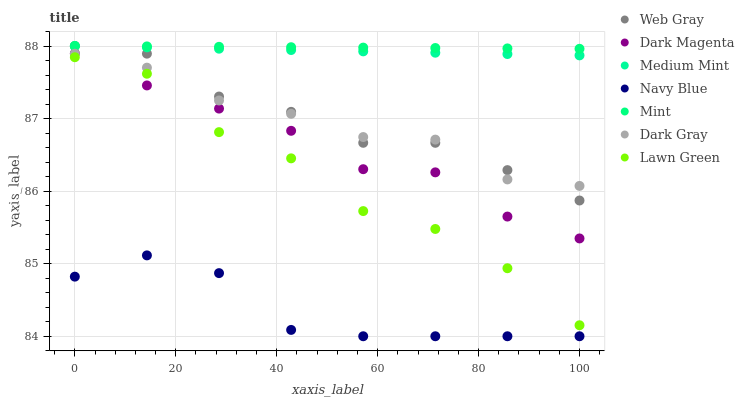Does Navy Blue have the minimum area under the curve?
Answer yes or no. Yes. Does Mint have the maximum area under the curve?
Answer yes or no. Yes. Does Lawn Green have the minimum area under the curve?
Answer yes or no. No. Does Lawn Green have the maximum area under the curve?
Answer yes or no. No. Is Mint the smoothest?
Answer yes or no. Yes. Is Lawn Green the roughest?
Answer yes or no. Yes. Is Web Gray the smoothest?
Answer yes or no. No. Is Web Gray the roughest?
Answer yes or no. No. Does Navy Blue have the lowest value?
Answer yes or no. Yes. Does Lawn Green have the lowest value?
Answer yes or no. No. Does Mint have the highest value?
Answer yes or no. Yes. Does Lawn Green have the highest value?
Answer yes or no. No. Is Dark Gray less than Medium Mint?
Answer yes or no. Yes. Is Medium Mint greater than Lawn Green?
Answer yes or no. Yes. Does Dark Gray intersect Web Gray?
Answer yes or no. Yes. Is Dark Gray less than Web Gray?
Answer yes or no. No. Is Dark Gray greater than Web Gray?
Answer yes or no. No. Does Dark Gray intersect Medium Mint?
Answer yes or no. No. 